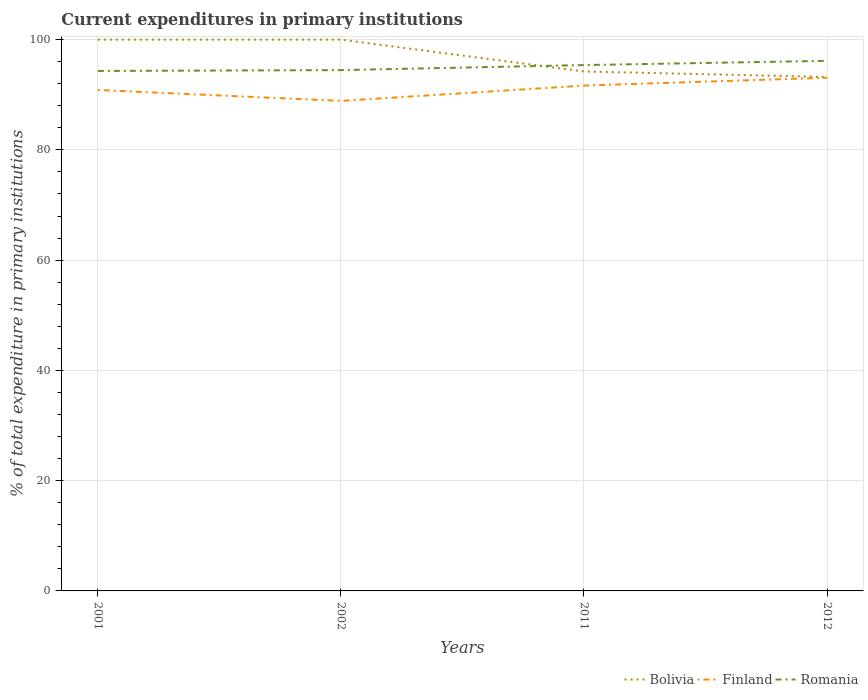How many different coloured lines are there?
Offer a terse response. 3. Does the line corresponding to Bolivia intersect with the line corresponding to Finland?
Your answer should be compact. No. Across all years, what is the maximum current expenditures in primary institutions in Bolivia?
Give a very brief answer. 93.23. In which year was the current expenditures in primary institutions in Romania maximum?
Your response must be concise. 2001. What is the total current expenditures in primary institutions in Romania in the graph?
Keep it short and to the point. -0.91. What is the difference between the highest and the second highest current expenditures in primary institutions in Finland?
Your answer should be very brief. 4.2. What is the difference between the highest and the lowest current expenditures in primary institutions in Bolivia?
Make the answer very short. 2. Is the current expenditures in primary institutions in Finland strictly greater than the current expenditures in primary institutions in Bolivia over the years?
Offer a terse response. Yes. How many years are there in the graph?
Your answer should be compact. 4. Are the values on the major ticks of Y-axis written in scientific E-notation?
Your answer should be very brief. No. Does the graph contain any zero values?
Your answer should be compact. No. Where does the legend appear in the graph?
Give a very brief answer. Bottom right. How many legend labels are there?
Provide a short and direct response. 3. What is the title of the graph?
Make the answer very short. Current expenditures in primary institutions. Does "OECD members" appear as one of the legend labels in the graph?
Make the answer very short. No. What is the label or title of the Y-axis?
Your response must be concise. % of total expenditure in primary institutions. What is the % of total expenditure in primary institutions of Bolivia in 2001?
Offer a very short reply. 100. What is the % of total expenditure in primary institutions in Finland in 2001?
Make the answer very short. 90.87. What is the % of total expenditure in primary institutions of Romania in 2001?
Offer a very short reply. 94.32. What is the % of total expenditure in primary institutions of Finland in 2002?
Give a very brief answer. 88.89. What is the % of total expenditure in primary institutions in Romania in 2002?
Provide a succinct answer. 94.47. What is the % of total expenditure in primary institutions in Bolivia in 2011?
Offer a terse response. 94.22. What is the % of total expenditure in primary institutions in Finland in 2011?
Make the answer very short. 91.67. What is the % of total expenditure in primary institutions in Romania in 2011?
Give a very brief answer. 95.39. What is the % of total expenditure in primary institutions of Bolivia in 2012?
Offer a terse response. 93.23. What is the % of total expenditure in primary institutions in Finland in 2012?
Offer a very short reply. 93.09. What is the % of total expenditure in primary institutions of Romania in 2012?
Ensure brevity in your answer.  96.16. Across all years, what is the maximum % of total expenditure in primary institutions of Finland?
Your answer should be very brief. 93.09. Across all years, what is the maximum % of total expenditure in primary institutions of Romania?
Make the answer very short. 96.16. Across all years, what is the minimum % of total expenditure in primary institutions of Bolivia?
Your answer should be compact. 93.23. Across all years, what is the minimum % of total expenditure in primary institutions in Finland?
Your answer should be compact. 88.89. Across all years, what is the minimum % of total expenditure in primary institutions of Romania?
Make the answer very short. 94.32. What is the total % of total expenditure in primary institutions in Bolivia in the graph?
Provide a short and direct response. 387.45. What is the total % of total expenditure in primary institutions of Finland in the graph?
Provide a short and direct response. 364.52. What is the total % of total expenditure in primary institutions of Romania in the graph?
Keep it short and to the point. 380.34. What is the difference between the % of total expenditure in primary institutions in Bolivia in 2001 and that in 2002?
Ensure brevity in your answer.  0. What is the difference between the % of total expenditure in primary institutions of Finland in 2001 and that in 2002?
Make the answer very short. 1.98. What is the difference between the % of total expenditure in primary institutions in Romania in 2001 and that in 2002?
Your answer should be very brief. -0.15. What is the difference between the % of total expenditure in primary institutions in Bolivia in 2001 and that in 2011?
Your answer should be compact. 5.78. What is the difference between the % of total expenditure in primary institutions in Finland in 2001 and that in 2011?
Keep it short and to the point. -0.8. What is the difference between the % of total expenditure in primary institutions in Romania in 2001 and that in 2011?
Provide a short and direct response. -1.07. What is the difference between the % of total expenditure in primary institutions in Bolivia in 2001 and that in 2012?
Provide a succinct answer. 6.77. What is the difference between the % of total expenditure in primary institutions in Finland in 2001 and that in 2012?
Offer a very short reply. -2.22. What is the difference between the % of total expenditure in primary institutions of Romania in 2001 and that in 2012?
Offer a terse response. -1.84. What is the difference between the % of total expenditure in primary institutions of Bolivia in 2002 and that in 2011?
Provide a succinct answer. 5.78. What is the difference between the % of total expenditure in primary institutions in Finland in 2002 and that in 2011?
Provide a short and direct response. -2.78. What is the difference between the % of total expenditure in primary institutions in Romania in 2002 and that in 2011?
Provide a succinct answer. -0.91. What is the difference between the % of total expenditure in primary institutions in Bolivia in 2002 and that in 2012?
Offer a terse response. 6.77. What is the difference between the % of total expenditure in primary institutions in Finland in 2002 and that in 2012?
Make the answer very short. -4.2. What is the difference between the % of total expenditure in primary institutions in Romania in 2002 and that in 2012?
Provide a succinct answer. -1.68. What is the difference between the % of total expenditure in primary institutions in Bolivia in 2011 and that in 2012?
Keep it short and to the point. 0.99. What is the difference between the % of total expenditure in primary institutions of Finland in 2011 and that in 2012?
Your response must be concise. -1.42. What is the difference between the % of total expenditure in primary institutions in Romania in 2011 and that in 2012?
Provide a succinct answer. -0.77. What is the difference between the % of total expenditure in primary institutions of Bolivia in 2001 and the % of total expenditure in primary institutions of Finland in 2002?
Your answer should be compact. 11.11. What is the difference between the % of total expenditure in primary institutions of Bolivia in 2001 and the % of total expenditure in primary institutions of Romania in 2002?
Provide a succinct answer. 5.53. What is the difference between the % of total expenditure in primary institutions in Finland in 2001 and the % of total expenditure in primary institutions in Romania in 2002?
Offer a very short reply. -3.61. What is the difference between the % of total expenditure in primary institutions in Bolivia in 2001 and the % of total expenditure in primary institutions in Finland in 2011?
Your response must be concise. 8.33. What is the difference between the % of total expenditure in primary institutions in Bolivia in 2001 and the % of total expenditure in primary institutions in Romania in 2011?
Give a very brief answer. 4.61. What is the difference between the % of total expenditure in primary institutions of Finland in 2001 and the % of total expenditure in primary institutions of Romania in 2011?
Give a very brief answer. -4.52. What is the difference between the % of total expenditure in primary institutions in Bolivia in 2001 and the % of total expenditure in primary institutions in Finland in 2012?
Your answer should be compact. 6.91. What is the difference between the % of total expenditure in primary institutions in Bolivia in 2001 and the % of total expenditure in primary institutions in Romania in 2012?
Offer a terse response. 3.84. What is the difference between the % of total expenditure in primary institutions of Finland in 2001 and the % of total expenditure in primary institutions of Romania in 2012?
Offer a terse response. -5.29. What is the difference between the % of total expenditure in primary institutions of Bolivia in 2002 and the % of total expenditure in primary institutions of Finland in 2011?
Ensure brevity in your answer.  8.33. What is the difference between the % of total expenditure in primary institutions in Bolivia in 2002 and the % of total expenditure in primary institutions in Romania in 2011?
Offer a terse response. 4.61. What is the difference between the % of total expenditure in primary institutions of Finland in 2002 and the % of total expenditure in primary institutions of Romania in 2011?
Offer a very short reply. -6.5. What is the difference between the % of total expenditure in primary institutions in Bolivia in 2002 and the % of total expenditure in primary institutions in Finland in 2012?
Provide a succinct answer. 6.91. What is the difference between the % of total expenditure in primary institutions of Bolivia in 2002 and the % of total expenditure in primary institutions of Romania in 2012?
Your response must be concise. 3.84. What is the difference between the % of total expenditure in primary institutions of Finland in 2002 and the % of total expenditure in primary institutions of Romania in 2012?
Keep it short and to the point. -7.27. What is the difference between the % of total expenditure in primary institutions in Bolivia in 2011 and the % of total expenditure in primary institutions in Finland in 2012?
Keep it short and to the point. 1.13. What is the difference between the % of total expenditure in primary institutions in Bolivia in 2011 and the % of total expenditure in primary institutions in Romania in 2012?
Keep it short and to the point. -1.93. What is the difference between the % of total expenditure in primary institutions of Finland in 2011 and the % of total expenditure in primary institutions of Romania in 2012?
Your answer should be compact. -4.49. What is the average % of total expenditure in primary institutions of Bolivia per year?
Ensure brevity in your answer.  96.86. What is the average % of total expenditure in primary institutions in Finland per year?
Provide a succinct answer. 91.13. What is the average % of total expenditure in primary institutions in Romania per year?
Ensure brevity in your answer.  95.08. In the year 2001, what is the difference between the % of total expenditure in primary institutions in Bolivia and % of total expenditure in primary institutions in Finland?
Ensure brevity in your answer.  9.13. In the year 2001, what is the difference between the % of total expenditure in primary institutions of Bolivia and % of total expenditure in primary institutions of Romania?
Give a very brief answer. 5.68. In the year 2001, what is the difference between the % of total expenditure in primary institutions of Finland and % of total expenditure in primary institutions of Romania?
Keep it short and to the point. -3.45. In the year 2002, what is the difference between the % of total expenditure in primary institutions in Bolivia and % of total expenditure in primary institutions in Finland?
Ensure brevity in your answer.  11.11. In the year 2002, what is the difference between the % of total expenditure in primary institutions in Bolivia and % of total expenditure in primary institutions in Romania?
Keep it short and to the point. 5.53. In the year 2002, what is the difference between the % of total expenditure in primary institutions of Finland and % of total expenditure in primary institutions of Romania?
Make the answer very short. -5.58. In the year 2011, what is the difference between the % of total expenditure in primary institutions in Bolivia and % of total expenditure in primary institutions in Finland?
Ensure brevity in your answer.  2.55. In the year 2011, what is the difference between the % of total expenditure in primary institutions in Bolivia and % of total expenditure in primary institutions in Romania?
Provide a succinct answer. -1.16. In the year 2011, what is the difference between the % of total expenditure in primary institutions of Finland and % of total expenditure in primary institutions of Romania?
Provide a succinct answer. -3.72. In the year 2012, what is the difference between the % of total expenditure in primary institutions in Bolivia and % of total expenditure in primary institutions in Finland?
Offer a terse response. 0.14. In the year 2012, what is the difference between the % of total expenditure in primary institutions in Bolivia and % of total expenditure in primary institutions in Romania?
Offer a terse response. -2.93. In the year 2012, what is the difference between the % of total expenditure in primary institutions in Finland and % of total expenditure in primary institutions in Romania?
Offer a very short reply. -3.06. What is the ratio of the % of total expenditure in primary institutions in Finland in 2001 to that in 2002?
Your answer should be compact. 1.02. What is the ratio of the % of total expenditure in primary institutions in Romania in 2001 to that in 2002?
Ensure brevity in your answer.  1. What is the ratio of the % of total expenditure in primary institutions in Bolivia in 2001 to that in 2011?
Make the answer very short. 1.06. What is the ratio of the % of total expenditure in primary institutions of Bolivia in 2001 to that in 2012?
Make the answer very short. 1.07. What is the ratio of the % of total expenditure in primary institutions of Finland in 2001 to that in 2012?
Give a very brief answer. 0.98. What is the ratio of the % of total expenditure in primary institutions of Romania in 2001 to that in 2012?
Provide a succinct answer. 0.98. What is the ratio of the % of total expenditure in primary institutions of Bolivia in 2002 to that in 2011?
Make the answer very short. 1.06. What is the ratio of the % of total expenditure in primary institutions in Finland in 2002 to that in 2011?
Keep it short and to the point. 0.97. What is the ratio of the % of total expenditure in primary institutions in Romania in 2002 to that in 2011?
Offer a very short reply. 0.99. What is the ratio of the % of total expenditure in primary institutions of Bolivia in 2002 to that in 2012?
Give a very brief answer. 1.07. What is the ratio of the % of total expenditure in primary institutions of Finland in 2002 to that in 2012?
Keep it short and to the point. 0.95. What is the ratio of the % of total expenditure in primary institutions of Romania in 2002 to that in 2012?
Make the answer very short. 0.98. What is the ratio of the % of total expenditure in primary institutions of Bolivia in 2011 to that in 2012?
Provide a succinct answer. 1.01. What is the ratio of the % of total expenditure in primary institutions in Finland in 2011 to that in 2012?
Provide a succinct answer. 0.98. What is the ratio of the % of total expenditure in primary institutions of Romania in 2011 to that in 2012?
Make the answer very short. 0.99. What is the difference between the highest and the second highest % of total expenditure in primary institutions in Finland?
Your answer should be compact. 1.42. What is the difference between the highest and the second highest % of total expenditure in primary institutions in Romania?
Ensure brevity in your answer.  0.77. What is the difference between the highest and the lowest % of total expenditure in primary institutions in Bolivia?
Provide a short and direct response. 6.77. What is the difference between the highest and the lowest % of total expenditure in primary institutions in Finland?
Your answer should be very brief. 4.2. What is the difference between the highest and the lowest % of total expenditure in primary institutions in Romania?
Provide a short and direct response. 1.84. 